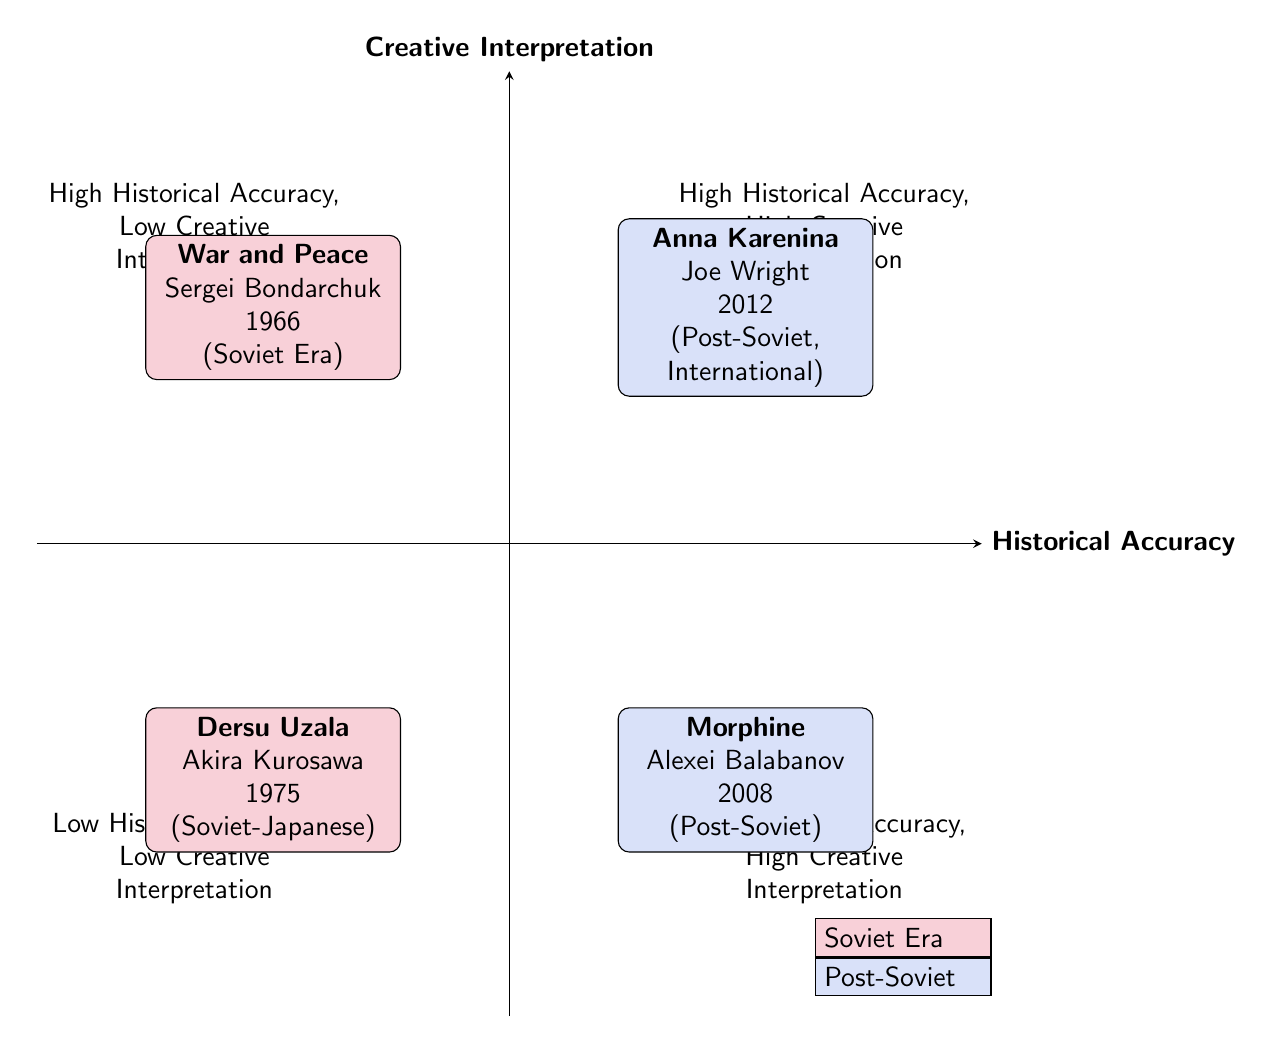What is the title of the film located in the top-left quadrant? The top-left quadrant is labeled "High Historical Accuracy, Low Creative Interpretation." The film found in this quadrant is "War and Peace."
Answer: War and Peace How many films are in the bottom-right quadrant? The bottom-right quadrant, which is labeled "Low Historical Accuracy, High Creative Interpretation," contains one film, which is "Morphine."
Answer: 1 Who directed the film "Dersu Uzala"? "Dersu Uzala" is located in the bottom-left quadrant and was directed by Akira Kurosawa.
Answer: Akira Kurosawa Which quadrant contains films that are both high in historical accuracy and high in creative interpretation? The top-right quadrant features films that are both high in historical accuracy and high in creative interpretation, including "Anna Karenina."
Answer: Top-right Is "Morphine" a Soviet or Post-Soviet adaptation? "Morphine" is located in the bottom-right quadrant and is identified as a Post-Soviet adaptation.
Answer: Post-Soviet What are the production characteristics of the film "War and Peace"? "War and Peace" is found in the top-left quadrant and is a product of the Soviet Era, being marked with its director and year as "1966."
Answer: Soviet Era What is the relationship between "Anna Karenina" and "Dersu Uzala" in terms of historical accuracy? "Anna Karenina" is positioned in the top-right quadrant with high historical accuracy, while "Dersu Uzala," located in the bottom-left quadrant, has low historical accuracy, showing a contrast in their representations.
Answer: Contrasting What is the year of release for the film "Morphine"? "Morphine," which is in the bottom-right quadrant, was released in the year 2008.
Answer: 2008 